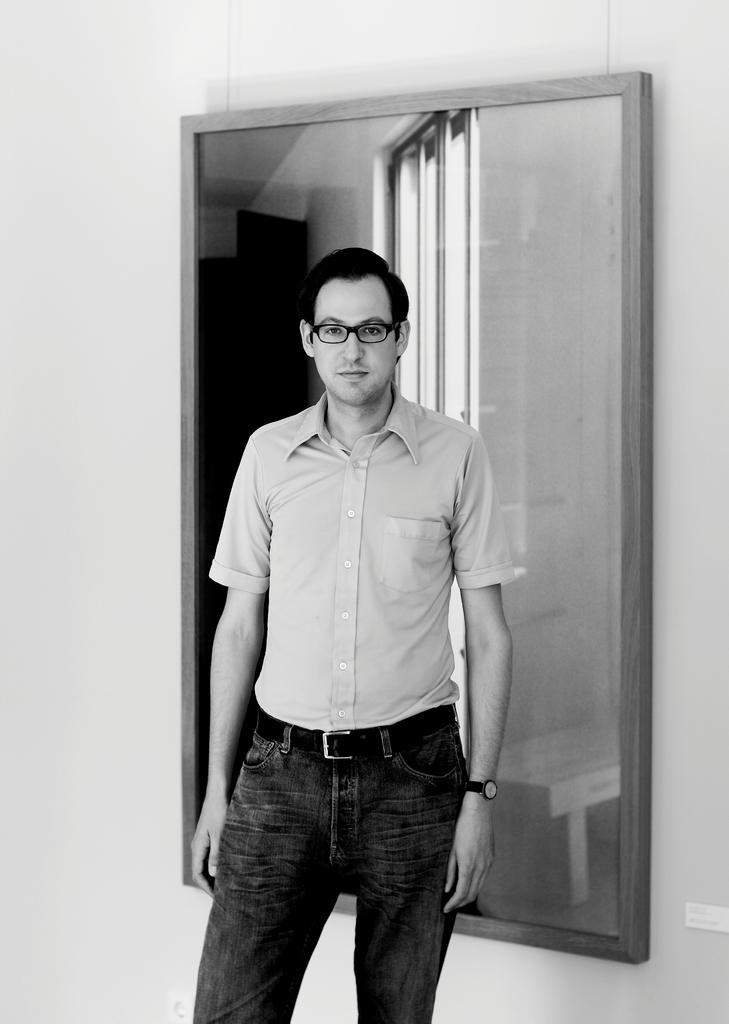Could you give a brief overview of what you see in this image? This is a black and white picture. In this picture, we see a man is standing. He is wearing the spectacles and a watch. He might be posing for the photo. Behind him, we see a white wall and a mirror is placed on the wall. We see the windows, wall and a bench in the mirror. 